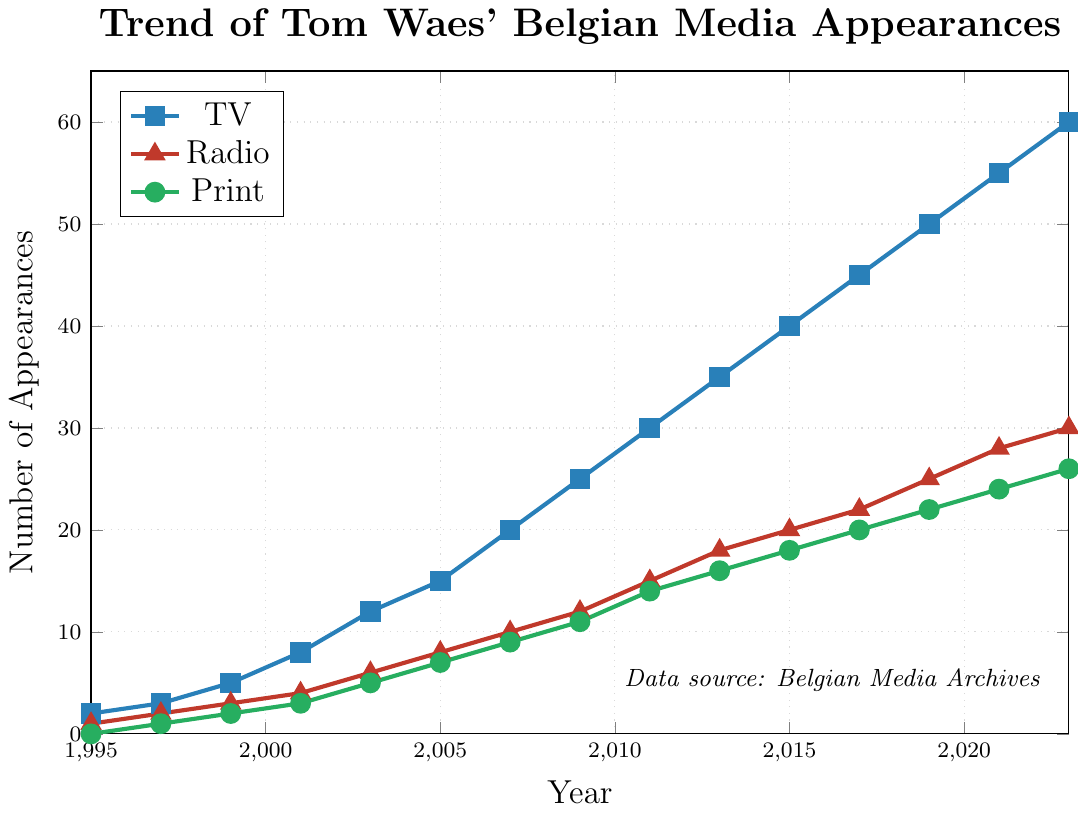What is the total number of Tom Waes' TV appearances in 2023? The graph shows that the number of TV appearances in 2023 has reached 60. Simply refer to the plotted line representing TV appearances and locate the point at 2023.
Answer: 60 By how much did Tom Waes' radio appearances increase between 2011 and 2021? In 2011, Tom Waes had 15 radio appearances and this increases to 28 by 2021. The difference is 28 - 15 = 13.
Answer: 13 Which type of media appearance had the highest count in 2009? In 2009, the graph shows TV appearances at 25, radio at 12, and print at 11. TV appearances are the highest among the three.
Answer: TV What is the cumulative number of print appearances from 1995 to 2005? Sum the number of print appearances from 1995 (0), 1997 (1), 1999 (2), 2001 (3), 2003 (5), and 2005 (7): 0 + 1 + 2 + 3 + 5 + 7 = 18.
Answer: 18 What is the ratio of TV to print appearances in 2003? In 2003, the number of TV appearances is 12 and print appearances is 5. The ratio is 12:5, or in simplest form, it is 12/5 (or 2.4).
Answer: 2.4 Compare the slopes of the trend lines between TV and radio appearances between 2011 to 2015. Which one has a steeper incline? Between 2011 (30) and 2015 (40), TV appearances increase by 10 (40-30). The radio appearances between 2011 (15) and 2015 (20) increase by 5 (20-15). The slope, calculated as increase/year, is 10/4 = 2.5 for TV and 5/4 = 1.25 for radio. Therefore, the TV appearances trend line has a steeper incline.
Answer: TV What average number of appearances per year did Tom Waes have in print from 1995 to 2023? The total number of print appearances over the years 1995 to 2023 sums up to 144 (0 + 1 + 2 + 3 + 5 + 7 + 9 + 11 + 14 + 16 + 18 + 20 + 22 + 24 + 26 = 178), and the duration is 2023-1995 = 28 years. The average per year is 178/28 ≈ 6.36.
Answer: 6.36 How do the media appearances compare visually in terms of color and shape of the markers? The TV appearances are indicated by blue square markers, radio appearances by red triangle markers, and print appearances by green circular markers. These visual attributes help distinguish between the different types of media appearances.
Answer: Blue squares (TV), Red triangles (Radio), Green circles (Print) 